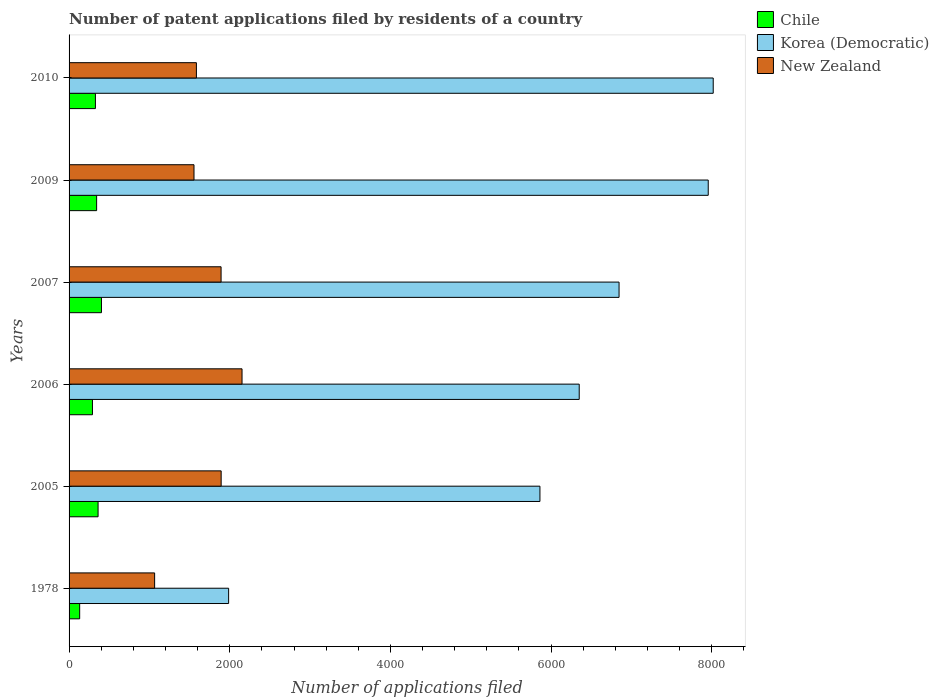How many different coloured bars are there?
Ensure brevity in your answer.  3. Are the number of bars per tick equal to the number of legend labels?
Your answer should be very brief. Yes. Are the number of bars on each tick of the Y-axis equal?
Keep it short and to the point. Yes. How many bars are there on the 1st tick from the top?
Provide a succinct answer. 3. In how many cases, is the number of bars for a given year not equal to the number of legend labels?
Your answer should be very brief. 0. What is the number of applications filed in New Zealand in 2009?
Ensure brevity in your answer.  1555. Across all years, what is the maximum number of applications filed in New Zealand?
Your response must be concise. 2153. Across all years, what is the minimum number of applications filed in New Zealand?
Offer a terse response. 1065. In which year was the number of applications filed in Korea (Democratic) maximum?
Provide a succinct answer. 2010. In which year was the number of applications filed in Chile minimum?
Provide a succinct answer. 1978. What is the total number of applications filed in Korea (Democratic) in the graph?
Keep it short and to the point. 3.70e+04. What is the difference between the number of applications filed in Korea (Democratic) in 2006 and that in 2009?
Make the answer very short. -1606. What is the difference between the number of applications filed in Korea (Democratic) in 2006 and the number of applications filed in Chile in 1978?
Give a very brief answer. 6218. What is the average number of applications filed in Korea (Democratic) per year?
Your response must be concise. 6169.5. In the year 2006, what is the difference between the number of applications filed in Korea (Democratic) and number of applications filed in New Zealand?
Your answer should be very brief. 4197. What is the ratio of the number of applications filed in New Zealand in 1978 to that in 2007?
Provide a succinct answer. 0.56. Is the number of applications filed in Chile in 2005 less than that in 2009?
Your answer should be very brief. No. What is the difference between the highest and the lowest number of applications filed in Korea (Democratic)?
Your answer should be compact. 6032. Is the sum of the number of applications filed in Chile in 2006 and 2007 greater than the maximum number of applications filed in Korea (Democratic) across all years?
Your response must be concise. No. Is it the case that in every year, the sum of the number of applications filed in Chile and number of applications filed in New Zealand is greater than the number of applications filed in Korea (Democratic)?
Keep it short and to the point. No. Are the values on the major ticks of X-axis written in scientific E-notation?
Your answer should be compact. No. Does the graph contain grids?
Keep it short and to the point. No. Where does the legend appear in the graph?
Offer a terse response. Top right. What is the title of the graph?
Provide a short and direct response. Number of patent applications filed by residents of a country. What is the label or title of the X-axis?
Provide a succinct answer. Number of applications filed. What is the label or title of the Y-axis?
Give a very brief answer. Years. What is the Number of applications filed in Chile in 1978?
Ensure brevity in your answer.  132. What is the Number of applications filed in Korea (Democratic) in 1978?
Keep it short and to the point. 1986. What is the Number of applications filed of New Zealand in 1978?
Provide a short and direct response. 1065. What is the Number of applications filed in Chile in 2005?
Give a very brief answer. 361. What is the Number of applications filed in Korea (Democratic) in 2005?
Your answer should be compact. 5861. What is the Number of applications filed of New Zealand in 2005?
Ensure brevity in your answer.  1893. What is the Number of applications filed of Chile in 2006?
Provide a short and direct response. 291. What is the Number of applications filed of Korea (Democratic) in 2006?
Ensure brevity in your answer.  6350. What is the Number of applications filed in New Zealand in 2006?
Offer a terse response. 2153. What is the Number of applications filed in Chile in 2007?
Your response must be concise. 403. What is the Number of applications filed in Korea (Democratic) in 2007?
Ensure brevity in your answer.  6846. What is the Number of applications filed in New Zealand in 2007?
Provide a short and direct response. 1892. What is the Number of applications filed in Chile in 2009?
Your answer should be very brief. 343. What is the Number of applications filed of Korea (Democratic) in 2009?
Offer a terse response. 7956. What is the Number of applications filed of New Zealand in 2009?
Offer a terse response. 1555. What is the Number of applications filed of Chile in 2010?
Keep it short and to the point. 328. What is the Number of applications filed in Korea (Democratic) in 2010?
Give a very brief answer. 8018. What is the Number of applications filed in New Zealand in 2010?
Your answer should be very brief. 1585. Across all years, what is the maximum Number of applications filed of Chile?
Provide a succinct answer. 403. Across all years, what is the maximum Number of applications filed of Korea (Democratic)?
Keep it short and to the point. 8018. Across all years, what is the maximum Number of applications filed in New Zealand?
Your answer should be very brief. 2153. Across all years, what is the minimum Number of applications filed in Chile?
Offer a terse response. 132. Across all years, what is the minimum Number of applications filed of Korea (Democratic)?
Offer a very short reply. 1986. Across all years, what is the minimum Number of applications filed of New Zealand?
Ensure brevity in your answer.  1065. What is the total Number of applications filed of Chile in the graph?
Your response must be concise. 1858. What is the total Number of applications filed in Korea (Democratic) in the graph?
Keep it short and to the point. 3.70e+04. What is the total Number of applications filed in New Zealand in the graph?
Offer a terse response. 1.01e+04. What is the difference between the Number of applications filed of Chile in 1978 and that in 2005?
Keep it short and to the point. -229. What is the difference between the Number of applications filed in Korea (Democratic) in 1978 and that in 2005?
Make the answer very short. -3875. What is the difference between the Number of applications filed of New Zealand in 1978 and that in 2005?
Provide a short and direct response. -828. What is the difference between the Number of applications filed in Chile in 1978 and that in 2006?
Your response must be concise. -159. What is the difference between the Number of applications filed of Korea (Democratic) in 1978 and that in 2006?
Provide a short and direct response. -4364. What is the difference between the Number of applications filed of New Zealand in 1978 and that in 2006?
Give a very brief answer. -1088. What is the difference between the Number of applications filed of Chile in 1978 and that in 2007?
Give a very brief answer. -271. What is the difference between the Number of applications filed of Korea (Democratic) in 1978 and that in 2007?
Offer a very short reply. -4860. What is the difference between the Number of applications filed in New Zealand in 1978 and that in 2007?
Your response must be concise. -827. What is the difference between the Number of applications filed of Chile in 1978 and that in 2009?
Make the answer very short. -211. What is the difference between the Number of applications filed of Korea (Democratic) in 1978 and that in 2009?
Ensure brevity in your answer.  -5970. What is the difference between the Number of applications filed of New Zealand in 1978 and that in 2009?
Ensure brevity in your answer.  -490. What is the difference between the Number of applications filed of Chile in 1978 and that in 2010?
Give a very brief answer. -196. What is the difference between the Number of applications filed in Korea (Democratic) in 1978 and that in 2010?
Your answer should be compact. -6032. What is the difference between the Number of applications filed of New Zealand in 1978 and that in 2010?
Give a very brief answer. -520. What is the difference between the Number of applications filed of Chile in 2005 and that in 2006?
Keep it short and to the point. 70. What is the difference between the Number of applications filed in Korea (Democratic) in 2005 and that in 2006?
Make the answer very short. -489. What is the difference between the Number of applications filed of New Zealand in 2005 and that in 2006?
Provide a succinct answer. -260. What is the difference between the Number of applications filed of Chile in 2005 and that in 2007?
Ensure brevity in your answer.  -42. What is the difference between the Number of applications filed of Korea (Democratic) in 2005 and that in 2007?
Make the answer very short. -985. What is the difference between the Number of applications filed of New Zealand in 2005 and that in 2007?
Your answer should be compact. 1. What is the difference between the Number of applications filed of Chile in 2005 and that in 2009?
Provide a short and direct response. 18. What is the difference between the Number of applications filed in Korea (Democratic) in 2005 and that in 2009?
Give a very brief answer. -2095. What is the difference between the Number of applications filed of New Zealand in 2005 and that in 2009?
Your answer should be very brief. 338. What is the difference between the Number of applications filed in Chile in 2005 and that in 2010?
Provide a succinct answer. 33. What is the difference between the Number of applications filed of Korea (Democratic) in 2005 and that in 2010?
Provide a succinct answer. -2157. What is the difference between the Number of applications filed of New Zealand in 2005 and that in 2010?
Keep it short and to the point. 308. What is the difference between the Number of applications filed in Chile in 2006 and that in 2007?
Offer a very short reply. -112. What is the difference between the Number of applications filed in Korea (Democratic) in 2006 and that in 2007?
Your answer should be very brief. -496. What is the difference between the Number of applications filed of New Zealand in 2006 and that in 2007?
Give a very brief answer. 261. What is the difference between the Number of applications filed of Chile in 2006 and that in 2009?
Offer a very short reply. -52. What is the difference between the Number of applications filed of Korea (Democratic) in 2006 and that in 2009?
Your answer should be very brief. -1606. What is the difference between the Number of applications filed in New Zealand in 2006 and that in 2009?
Your response must be concise. 598. What is the difference between the Number of applications filed of Chile in 2006 and that in 2010?
Provide a succinct answer. -37. What is the difference between the Number of applications filed of Korea (Democratic) in 2006 and that in 2010?
Keep it short and to the point. -1668. What is the difference between the Number of applications filed of New Zealand in 2006 and that in 2010?
Your answer should be compact. 568. What is the difference between the Number of applications filed in Chile in 2007 and that in 2009?
Ensure brevity in your answer.  60. What is the difference between the Number of applications filed in Korea (Democratic) in 2007 and that in 2009?
Keep it short and to the point. -1110. What is the difference between the Number of applications filed in New Zealand in 2007 and that in 2009?
Make the answer very short. 337. What is the difference between the Number of applications filed of Korea (Democratic) in 2007 and that in 2010?
Your answer should be very brief. -1172. What is the difference between the Number of applications filed of New Zealand in 2007 and that in 2010?
Offer a terse response. 307. What is the difference between the Number of applications filed in Korea (Democratic) in 2009 and that in 2010?
Your answer should be very brief. -62. What is the difference between the Number of applications filed of Chile in 1978 and the Number of applications filed of Korea (Democratic) in 2005?
Your answer should be very brief. -5729. What is the difference between the Number of applications filed of Chile in 1978 and the Number of applications filed of New Zealand in 2005?
Your answer should be very brief. -1761. What is the difference between the Number of applications filed in Korea (Democratic) in 1978 and the Number of applications filed in New Zealand in 2005?
Keep it short and to the point. 93. What is the difference between the Number of applications filed of Chile in 1978 and the Number of applications filed of Korea (Democratic) in 2006?
Give a very brief answer. -6218. What is the difference between the Number of applications filed of Chile in 1978 and the Number of applications filed of New Zealand in 2006?
Your answer should be compact. -2021. What is the difference between the Number of applications filed of Korea (Democratic) in 1978 and the Number of applications filed of New Zealand in 2006?
Provide a short and direct response. -167. What is the difference between the Number of applications filed in Chile in 1978 and the Number of applications filed in Korea (Democratic) in 2007?
Give a very brief answer. -6714. What is the difference between the Number of applications filed in Chile in 1978 and the Number of applications filed in New Zealand in 2007?
Give a very brief answer. -1760. What is the difference between the Number of applications filed of Korea (Democratic) in 1978 and the Number of applications filed of New Zealand in 2007?
Provide a succinct answer. 94. What is the difference between the Number of applications filed of Chile in 1978 and the Number of applications filed of Korea (Democratic) in 2009?
Your answer should be very brief. -7824. What is the difference between the Number of applications filed of Chile in 1978 and the Number of applications filed of New Zealand in 2009?
Offer a terse response. -1423. What is the difference between the Number of applications filed of Korea (Democratic) in 1978 and the Number of applications filed of New Zealand in 2009?
Keep it short and to the point. 431. What is the difference between the Number of applications filed of Chile in 1978 and the Number of applications filed of Korea (Democratic) in 2010?
Make the answer very short. -7886. What is the difference between the Number of applications filed of Chile in 1978 and the Number of applications filed of New Zealand in 2010?
Offer a terse response. -1453. What is the difference between the Number of applications filed of Korea (Democratic) in 1978 and the Number of applications filed of New Zealand in 2010?
Ensure brevity in your answer.  401. What is the difference between the Number of applications filed in Chile in 2005 and the Number of applications filed in Korea (Democratic) in 2006?
Your answer should be very brief. -5989. What is the difference between the Number of applications filed of Chile in 2005 and the Number of applications filed of New Zealand in 2006?
Make the answer very short. -1792. What is the difference between the Number of applications filed of Korea (Democratic) in 2005 and the Number of applications filed of New Zealand in 2006?
Offer a terse response. 3708. What is the difference between the Number of applications filed of Chile in 2005 and the Number of applications filed of Korea (Democratic) in 2007?
Offer a very short reply. -6485. What is the difference between the Number of applications filed of Chile in 2005 and the Number of applications filed of New Zealand in 2007?
Offer a very short reply. -1531. What is the difference between the Number of applications filed in Korea (Democratic) in 2005 and the Number of applications filed in New Zealand in 2007?
Offer a very short reply. 3969. What is the difference between the Number of applications filed in Chile in 2005 and the Number of applications filed in Korea (Democratic) in 2009?
Your answer should be very brief. -7595. What is the difference between the Number of applications filed of Chile in 2005 and the Number of applications filed of New Zealand in 2009?
Keep it short and to the point. -1194. What is the difference between the Number of applications filed of Korea (Democratic) in 2005 and the Number of applications filed of New Zealand in 2009?
Your answer should be compact. 4306. What is the difference between the Number of applications filed of Chile in 2005 and the Number of applications filed of Korea (Democratic) in 2010?
Your response must be concise. -7657. What is the difference between the Number of applications filed of Chile in 2005 and the Number of applications filed of New Zealand in 2010?
Offer a terse response. -1224. What is the difference between the Number of applications filed of Korea (Democratic) in 2005 and the Number of applications filed of New Zealand in 2010?
Your response must be concise. 4276. What is the difference between the Number of applications filed of Chile in 2006 and the Number of applications filed of Korea (Democratic) in 2007?
Give a very brief answer. -6555. What is the difference between the Number of applications filed in Chile in 2006 and the Number of applications filed in New Zealand in 2007?
Your answer should be very brief. -1601. What is the difference between the Number of applications filed of Korea (Democratic) in 2006 and the Number of applications filed of New Zealand in 2007?
Your response must be concise. 4458. What is the difference between the Number of applications filed of Chile in 2006 and the Number of applications filed of Korea (Democratic) in 2009?
Your answer should be compact. -7665. What is the difference between the Number of applications filed in Chile in 2006 and the Number of applications filed in New Zealand in 2009?
Offer a very short reply. -1264. What is the difference between the Number of applications filed in Korea (Democratic) in 2006 and the Number of applications filed in New Zealand in 2009?
Keep it short and to the point. 4795. What is the difference between the Number of applications filed in Chile in 2006 and the Number of applications filed in Korea (Democratic) in 2010?
Make the answer very short. -7727. What is the difference between the Number of applications filed of Chile in 2006 and the Number of applications filed of New Zealand in 2010?
Provide a short and direct response. -1294. What is the difference between the Number of applications filed of Korea (Democratic) in 2006 and the Number of applications filed of New Zealand in 2010?
Offer a terse response. 4765. What is the difference between the Number of applications filed of Chile in 2007 and the Number of applications filed of Korea (Democratic) in 2009?
Offer a terse response. -7553. What is the difference between the Number of applications filed of Chile in 2007 and the Number of applications filed of New Zealand in 2009?
Keep it short and to the point. -1152. What is the difference between the Number of applications filed of Korea (Democratic) in 2007 and the Number of applications filed of New Zealand in 2009?
Your answer should be compact. 5291. What is the difference between the Number of applications filed of Chile in 2007 and the Number of applications filed of Korea (Democratic) in 2010?
Offer a terse response. -7615. What is the difference between the Number of applications filed of Chile in 2007 and the Number of applications filed of New Zealand in 2010?
Make the answer very short. -1182. What is the difference between the Number of applications filed of Korea (Democratic) in 2007 and the Number of applications filed of New Zealand in 2010?
Offer a terse response. 5261. What is the difference between the Number of applications filed in Chile in 2009 and the Number of applications filed in Korea (Democratic) in 2010?
Your answer should be compact. -7675. What is the difference between the Number of applications filed in Chile in 2009 and the Number of applications filed in New Zealand in 2010?
Your answer should be very brief. -1242. What is the difference between the Number of applications filed of Korea (Democratic) in 2009 and the Number of applications filed of New Zealand in 2010?
Your response must be concise. 6371. What is the average Number of applications filed in Chile per year?
Offer a terse response. 309.67. What is the average Number of applications filed in Korea (Democratic) per year?
Your response must be concise. 6169.5. What is the average Number of applications filed of New Zealand per year?
Your answer should be very brief. 1690.5. In the year 1978, what is the difference between the Number of applications filed in Chile and Number of applications filed in Korea (Democratic)?
Provide a short and direct response. -1854. In the year 1978, what is the difference between the Number of applications filed in Chile and Number of applications filed in New Zealand?
Make the answer very short. -933. In the year 1978, what is the difference between the Number of applications filed in Korea (Democratic) and Number of applications filed in New Zealand?
Make the answer very short. 921. In the year 2005, what is the difference between the Number of applications filed in Chile and Number of applications filed in Korea (Democratic)?
Offer a terse response. -5500. In the year 2005, what is the difference between the Number of applications filed of Chile and Number of applications filed of New Zealand?
Keep it short and to the point. -1532. In the year 2005, what is the difference between the Number of applications filed in Korea (Democratic) and Number of applications filed in New Zealand?
Keep it short and to the point. 3968. In the year 2006, what is the difference between the Number of applications filed in Chile and Number of applications filed in Korea (Democratic)?
Ensure brevity in your answer.  -6059. In the year 2006, what is the difference between the Number of applications filed in Chile and Number of applications filed in New Zealand?
Offer a very short reply. -1862. In the year 2006, what is the difference between the Number of applications filed of Korea (Democratic) and Number of applications filed of New Zealand?
Keep it short and to the point. 4197. In the year 2007, what is the difference between the Number of applications filed in Chile and Number of applications filed in Korea (Democratic)?
Ensure brevity in your answer.  -6443. In the year 2007, what is the difference between the Number of applications filed of Chile and Number of applications filed of New Zealand?
Provide a succinct answer. -1489. In the year 2007, what is the difference between the Number of applications filed in Korea (Democratic) and Number of applications filed in New Zealand?
Offer a terse response. 4954. In the year 2009, what is the difference between the Number of applications filed in Chile and Number of applications filed in Korea (Democratic)?
Keep it short and to the point. -7613. In the year 2009, what is the difference between the Number of applications filed in Chile and Number of applications filed in New Zealand?
Your answer should be compact. -1212. In the year 2009, what is the difference between the Number of applications filed of Korea (Democratic) and Number of applications filed of New Zealand?
Keep it short and to the point. 6401. In the year 2010, what is the difference between the Number of applications filed of Chile and Number of applications filed of Korea (Democratic)?
Provide a succinct answer. -7690. In the year 2010, what is the difference between the Number of applications filed in Chile and Number of applications filed in New Zealand?
Provide a short and direct response. -1257. In the year 2010, what is the difference between the Number of applications filed of Korea (Democratic) and Number of applications filed of New Zealand?
Your response must be concise. 6433. What is the ratio of the Number of applications filed of Chile in 1978 to that in 2005?
Provide a short and direct response. 0.37. What is the ratio of the Number of applications filed of Korea (Democratic) in 1978 to that in 2005?
Provide a short and direct response. 0.34. What is the ratio of the Number of applications filed of New Zealand in 1978 to that in 2005?
Your answer should be compact. 0.56. What is the ratio of the Number of applications filed of Chile in 1978 to that in 2006?
Offer a terse response. 0.45. What is the ratio of the Number of applications filed in Korea (Democratic) in 1978 to that in 2006?
Provide a short and direct response. 0.31. What is the ratio of the Number of applications filed in New Zealand in 1978 to that in 2006?
Your response must be concise. 0.49. What is the ratio of the Number of applications filed of Chile in 1978 to that in 2007?
Make the answer very short. 0.33. What is the ratio of the Number of applications filed in Korea (Democratic) in 1978 to that in 2007?
Offer a terse response. 0.29. What is the ratio of the Number of applications filed in New Zealand in 1978 to that in 2007?
Your answer should be compact. 0.56. What is the ratio of the Number of applications filed in Chile in 1978 to that in 2009?
Your answer should be compact. 0.38. What is the ratio of the Number of applications filed of Korea (Democratic) in 1978 to that in 2009?
Your response must be concise. 0.25. What is the ratio of the Number of applications filed in New Zealand in 1978 to that in 2009?
Your response must be concise. 0.68. What is the ratio of the Number of applications filed in Chile in 1978 to that in 2010?
Ensure brevity in your answer.  0.4. What is the ratio of the Number of applications filed of Korea (Democratic) in 1978 to that in 2010?
Your response must be concise. 0.25. What is the ratio of the Number of applications filed of New Zealand in 1978 to that in 2010?
Your answer should be compact. 0.67. What is the ratio of the Number of applications filed of Chile in 2005 to that in 2006?
Offer a very short reply. 1.24. What is the ratio of the Number of applications filed in Korea (Democratic) in 2005 to that in 2006?
Give a very brief answer. 0.92. What is the ratio of the Number of applications filed in New Zealand in 2005 to that in 2006?
Give a very brief answer. 0.88. What is the ratio of the Number of applications filed of Chile in 2005 to that in 2007?
Provide a short and direct response. 0.9. What is the ratio of the Number of applications filed of Korea (Democratic) in 2005 to that in 2007?
Give a very brief answer. 0.86. What is the ratio of the Number of applications filed in New Zealand in 2005 to that in 2007?
Give a very brief answer. 1. What is the ratio of the Number of applications filed in Chile in 2005 to that in 2009?
Your response must be concise. 1.05. What is the ratio of the Number of applications filed of Korea (Democratic) in 2005 to that in 2009?
Keep it short and to the point. 0.74. What is the ratio of the Number of applications filed of New Zealand in 2005 to that in 2009?
Provide a succinct answer. 1.22. What is the ratio of the Number of applications filed in Chile in 2005 to that in 2010?
Your answer should be compact. 1.1. What is the ratio of the Number of applications filed of Korea (Democratic) in 2005 to that in 2010?
Ensure brevity in your answer.  0.73. What is the ratio of the Number of applications filed in New Zealand in 2005 to that in 2010?
Ensure brevity in your answer.  1.19. What is the ratio of the Number of applications filed of Chile in 2006 to that in 2007?
Provide a short and direct response. 0.72. What is the ratio of the Number of applications filed in Korea (Democratic) in 2006 to that in 2007?
Your answer should be compact. 0.93. What is the ratio of the Number of applications filed in New Zealand in 2006 to that in 2007?
Your answer should be very brief. 1.14. What is the ratio of the Number of applications filed in Chile in 2006 to that in 2009?
Make the answer very short. 0.85. What is the ratio of the Number of applications filed in Korea (Democratic) in 2006 to that in 2009?
Offer a very short reply. 0.8. What is the ratio of the Number of applications filed in New Zealand in 2006 to that in 2009?
Offer a very short reply. 1.38. What is the ratio of the Number of applications filed of Chile in 2006 to that in 2010?
Your answer should be very brief. 0.89. What is the ratio of the Number of applications filed in Korea (Democratic) in 2006 to that in 2010?
Your answer should be compact. 0.79. What is the ratio of the Number of applications filed of New Zealand in 2006 to that in 2010?
Make the answer very short. 1.36. What is the ratio of the Number of applications filed of Chile in 2007 to that in 2009?
Your answer should be very brief. 1.17. What is the ratio of the Number of applications filed of Korea (Democratic) in 2007 to that in 2009?
Give a very brief answer. 0.86. What is the ratio of the Number of applications filed in New Zealand in 2007 to that in 2009?
Keep it short and to the point. 1.22. What is the ratio of the Number of applications filed in Chile in 2007 to that in 2010?
Keep it short and to the point. 1.23. What is the ratio of the Number of applications filed in Korea (Democratic) in 2007 to that in 2010?
Offer a terse response. 0.85. What is the ratio of the Number of applications filed in New Zealand in 2007 to that in 2010?
Your response must be concise. 1.19. What is the ratio of the Number of applications filed of Chile in 2009 to that in 2010?
Your answer should be very brief. 1.05. What is the ratio of the Number of applications filed of Korea (Democratic) in 2009 to that in 2010?
Your answer should be very brief. 0.99. What is the ratio of the Number of applications filed of New Zealand in 2009 to that in 2010?
Ensure brevity in your answer.  0.98. What is the difference between the highest and the second highest Number of applications filed in New Zealand?
Offer a terse response. 260. What is the difference between the highest and the lowest Number of applications filed of Chile?
Your response must be concise. 271. What is the difference between the highest and the lowest Number of applications filed of Korea (Democratic)?
Give a very brief answer. 6032. What is the difference between the highest and the lowest Number of applications filed in New Zealand?
Give a very brief answer. 1088. 